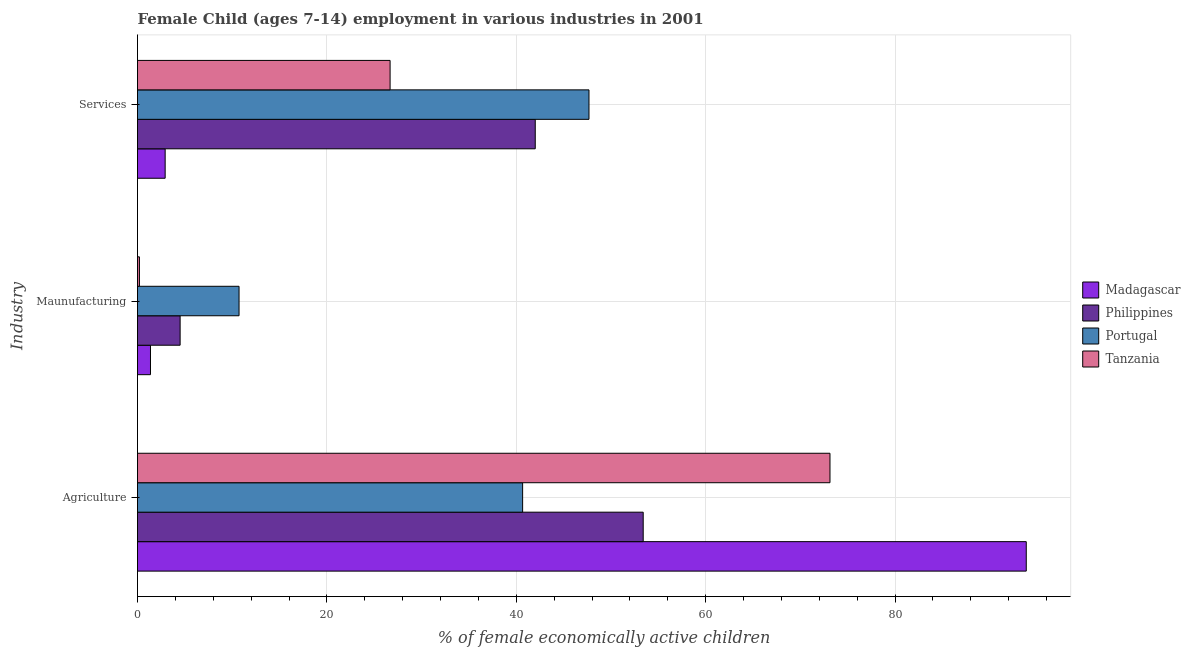How many groups of bars are there?
Ensure brevity in your answer.  3. How many bars are there on the 3rd tick from the top?
Provide a succinct answer. 4. What is the label of the 3rd group of bars from the top?
Ensure brevity in your answer.  Agriculture. What is the percentage of economically active children in services in Portugal?
Your answer should be very brief. 47.67. Across all countries, what is the maximum percentage of economically active children in manufacturing?
Make the answer very short. 10.72. Across all countries, what is the minimum percentage of economically active children in agriculture?
Give a very brief answer. 40.67. In which country was the percentage of economically active children in agriculture maximum?
Ensure brevity in your answer.  Madagascar. In which country was the percentage of economically active children in services minimum?
Make the answer very short. Madagascar. What is the total percentage of economically active children in services in the graph?
Your answer should be very brief. 119.27. What is the difference between the percentage of economically active children in agriculture in Tanzania and that in Portugal?
Your response must be concise. 32.46. What is the difference between the percentage of economically active children in services in Portugal and the percentage of economically active children in manufacturing in Philippines?
Give a very brief answer. 43.17. What is the average percentage of economically active children in agriculture per country?
Ensure brevity in your answer.  65.26. What is the difference between the percentage of economically active children in agriculture and percentage of economically active children in manufacturing in Portugal?
Your response must be concise. 29.94. What is the ratio of the percentage of economically active children in services in Philippines to that in Madagascar?
Give a very brief answer. 14.38. Is the percentage of economically active children in manufacturing in Tanzania less than that in Philippines?
Offer a terse response. Yes. What is the difference between the highest and the second highest percentage of economically active children in services?
Your response must be concise. 5.67. What is the difference between the highest and the lowest percentage of economically active children in manufacturing?
Your answer should be very brief. 10.52. Is the sum of the percentage of economically active children in manufacturing in Madagascar and Portugal greater than the maximum percentage of economically active children in agriculture across all countries?
Offer a very short reply. No. What does the 1st bar from the top in Maunufacturing represents?
Your response must be concise. Tanzania. What does the 1st bar from the bottom in Services represents?
Offer a very short reply. Madagascar. How many bars are there?
Make the answer very short. 12. Are all the bars in the graph horizontal?
Provide a short and direct response. Yes. What is the difference between two consecutive major ticks on the X-axis?
Your answer should be compact. 20. Does the graph contain grids?
Offer a very short reply. Yes. What is the title of the graph?
Your answer should be compact. Female Child (ages 7-14) employment in various industries in 2001. Does "Lebanon" appear as one of the legend labels in the graph?
Your response must be concise. No. What is the label or title of the X-axis?
Ensure brevity in your answer.  % of female economically active children. What is the label or title of the Y-axis?
Your response must be concise. Industry. What is the % of female economically active children in Madagascar in Agriculture?
Give a very brief answer. 93.85. What is the % of female economically active children of Philippines in Agriculture?
Your answer should be very brief. 53.4. What is the % of female economically active children of Portugal in Agriculture?
Make the answer very short. 40.67. What is the % of female economically active children of Tanzania in Agriculture?
Provide a short and direct response. 73.12. What is the % of female economically active children in Madagascar in Maunufacturing?
Provide a short and direct response. 1.37. What is the % of female economically active children of Philippines in Maunufacturing?
Provide a succinct answer. 4.5. What is the % of female economically active children in Portugal in Maunufacturing?
Your answer should be compact. 10.72. What is the % of female economically active children in Tanzania in Maunufacturing?
Give a very brief answer. 0.2. What is the % of female economically active children of Madagascar in Services?
Ensure brevity in your answer.  2.92. What is the % of female economically active children in Portugal in Services?
Your response must be concise. 47.67. What is the % of female economically active children in Tanzania in Services?
Your answer should be very brief. 26.67. Across all Industry, what is the maximum % of female economically active children of Madagascar?
Provide a succinct answer. 93.85. Across all Industry, what is the maximum % of female economically active children of Philippines?
Your response must be concise. 53.4. Across all Industry, what is the maximum % of female economically active children of Portugal?
Your answer should be compact. 47.67. Across all Industry, what is the maximum % of female economically active children of Tanzania?
Give a very brief answer. 73.12. Across all Industry, what is the minimum % of female economically active children of Madagascar?
Provide a short and direct response. 1.37. Across all Industry, what is the minimum % of female economically active children of Portugal?
Ensure brevity in your answer.  10.72. Across all Industry, what is the minimum % of female economically active children of Tanzania?
Offer a terse response. 0.2. What is the total % of female economically active children in Madagascar in the graph?
Provide a succinct answer. 98.14. What is the total % of female economically active children in Philippines in the graph?
Make the answer very short. 99.9. What is the total % of female economically active children of Portugal in the graph?
Offer a terse response. 99.06. What is the total % of female economically active children in Tanzania in the graph?
Provide a succinct answer. 100. What is the difference between the % of female economically active children of Madagascar in Agriculture and that in Maunufacturing?
Provide a succinct answer. 92.48. What is the difference between the % of female economically active children in Philippines in Agriculture and that in Maunufacturing?
Provide a succinct answer. 48.9. What is the difference between the % of female economically active children of Portugal in Agriculture and that in Maunufacturing?
Offer a terse response. 29.94. What is the difference between the % of female economically active children in Tanzania in Agriculture and that in Maunufacturing?
Provide a succinct answer. 72.92. What is the difference between the % of female economically active children of Madagascar in Agriculture and that in Services?
Provide a short and direct response. 90.93. What is the difference between the % of female economically active children of Portugal in Agriculture and that in Services?
Your response must be concise. -7.01. What is the difference between the % of female economically active children in Tanzania in Agriculture and that in Services?
Your response must be concise. 46.45. What is the difference between the % of female economically active children of Madagascar in Maunufacturing and that in Services?
Offer a terse response. -1.55. What is the difference between the % of female economically active children in Philippines in Maunufacturing and that in Services?
Provide a succinct answer. -37.5. What is the difference between the % of female economically active children in Portugal in Maunufacturing and that in Services?
Provide a short and direct response. -36.95. What is the difference between the % of female economically active children of Tanzania in Maunufacturing and that in Services?
Provide a short and direct response. -26.47. What is the difference between the % of female economically active children of Madagascar in Agriculture and the % of female economically active children of Philippines in Maunufacturing?
Your response must be concise. 89.35. What is the difference between the % of female economically active children of Madagascar in Agriculture and the % of female economically active children of Portugal in Maunufacturing?
Your response must be concise. 83.13. What is the difference between the % of female economically active children of Madagascar in Agriculture and the % of female economically active children of Tanzania in Maunufacturing?
Your answer should be very brief. 93.65. What is the difference between the % of female economically active children of Philippines in Agriculture and the % of female economically active children of Portugal in Maunufacturing?
Offer a terse response. 42.68. What is the difference between the % of female economically active children in Philippines in Agriculture and the % of female economically active children in Tanzania in Maunufacturing?
Make the answer very short. 53.2. What is the difference between the % of female economically active children of Portugal in Agriculture and the % of female economically active children of Tanzania in Maunufacturing?
Provide a short and direct response. 40.46. What is the difference between the % of female economically active children in Madagascar in Agriculture and the % of female economically active children in Philippines in Services?
Make the answer very short. 51.85. What is the difference between the % of female economically active children in Madagascar in Agriculture and the % of female economically active children in Portugal in Services?
Offer a very short reply. 46.18. What is the difference between the % of female economically active children in Madagascar in Agriculture and the % of female economically active children in Tanzania in Services?
Your response must be concise. 67.18. What is the difference between the % of female economically active children of Philippines in Agriculture and the % of female economically active children of Portugal in Services?
Your answer should be compact. 5.73. What is the difference between the % of female economically active children in Philippines in Agriculture and the % of female economically active children in Tanzania in Services?
Provide a succinct answer. 26.73. What is the difference between the % of female economically active children in Portugal in Agriculture and the % of female economically active children in Tanzania in Services?
Your response must be concise. 13.99. What is the difference between the % of female economically active children in Madagascar in Maunufacturing and the % of female economically active children in Philippines in Services?
Offer a very short reply. -40.63. What is the difference between the % of female economically active children in Madagascar in Maunufacturing and the % of female economically active children in Portugal in Services?
Your answer should be compact. -46.3. What is the difference between the % of female economically active children of Madagascar in Maunufacturing and the % of female economically active children of Tanzania in Services?
Offer a very short reply. -25.3. What is the difference between the % of female economically active children of Philippines in Maunufacturing and the % of female economically active children of Portugal in Services?
Ensure brevity in your answer.  -43.17. What is the difference between the % of female economically active children of Philippines in Maunufacturing and the % of female economically active children of Tanzania in Services?
Provide a succinct answer. -22.17. What is the difference between the % of female economically active children in Portugal in Maunufacturing and the % of female economically active children in Tanzania in Services?
Provide a succinct answer. -15.95. What is the average % of female economically active children of Madagascar per Industry?
Provide a succinct answer. 32.71. What is the average % of female economically active children in Philippines per Industry?
Offer a very short reply. 33.3. What is the average % of female economically active children of Portugal per Industry?
Keep it short and to the point. 33.02. What is the average % of female economically active children of Tanzania per Industry?
Your response must be concise. 33.33. What is the difference between the % of female economically active children in Madagascar and % of female economically active children in Philippines in Agriculture?
Give a very brief answer. 40.45. What is the difference between the % of female economically active children in Madagascar and % of female economically active children in Portugal in Agriculture?
Your answer should be compact. 53.18. What is the difference between the % of female economically active children in Madagascar and % of female economically active children in Tanzania in Agriculture?
Keep it short and to the point. 20.73. What is the difference between the % of female economically active children in Philippines and % of female economically active children in Portugal in Agriculture?
Provide a short and direct response. 12.73. What is the difference between the % of female economically active children in Philippines and % of female economically active children in Tanzania in Agriculture?
Provide a succinct answer. -19.72. What is the difference between the % of female economically active children of Portugal and % of female economically active children of Tanzania in Agriculture?
Your response must be concise. -32.46. What is the difference between the % of female economically active children of Madagascar and % of female economically active children of Philippines in Maunufacturing?
Your response must be concise. -3.13. What is the difference between the % of female economically active children of Madagascar and % of female economically active children of Portugal in Maunufacturing?
Keep it short and to the point. -9.35. What is the difference between the % of female economically active children of Madagascar and % of female economically active children of Tanzania in Maunufacturing?
Your answer should be very brief. 1.17. What is the difference between the % of female economically active children in Philippines and % of female economically active children in Portugal in Maunufacturing?
Your response must be concise. -6.22. What is the difference between the % of female economically active children of Philippines and % of female economically active children of Tanzania in Maunufacturing?
Provide a short and direct response. 4.3. What is the difference between the % of female economically active children of Portugal and % of female economically active children of Tanzania in Maunufacturing?
Ensure brevity in your answer.  10.52. What is the difference between the % of female economically active children of Madagascar and % of female economically active children of Philippines in Services?
Your answer should be compact. -39.08. What is the difference between the % of female economically active children in Madagascar and % of female economically active children in Portugal in Services?
Provide a short and direct response. -44.75. What is the difference between the % of female economically active children in Madagascar and % of female economically active children in Tanzania in Services?
Your answer should be compact. -23.75. What is the difference between the % of female economically active children of Philippines and % of female economically active children of Portugal in Services?
Offer a very short reply. -5.67. What is the difference between the % of female economically active children in Philippines and % of female economically active children in Tanzania in Services?
Make the answer very short. 15.33. What is the difference between the % of female economically active children of Portugal and % of female economically active children of Tanzania in Services?
Provide a short and direct response. 21. What is the ratio of the % of female economically active children in Madagascar in Agriculture to that in Maunufacturing?
Provide a short and direct response. 68.5. What is the ratio of the % of female economically active children in Philippines in Agriculture to that in Maunufacturing?
Offer a terse response. 11.87. What is the ratio of the % of female economically active children in Portugal in Agriculture to that in Maunufacturing?
Provide a short and direct response. 3.79. What is the ratio of the % of female economically active children in Tanzania in Agriculture to that in Maunufacturing?
Ensure brevity in your answer.  360.16. What is the ratio of the % of female economically active children of Madagascar in Agriculture to that in Services?
Keep it short and to the point. 32.14. What is the ratio of the % of female economically active children in Philippines in Agriculture to that in Services?
Offer a very short reply. 1.27. What is the ratio of the % of female economically active children of Portugal in Agriculture to that in Services?
Keep it short and to the point. 0.85. What is the ratio of the % of female economically active children in Tanzania in Agriculture to that in Services?
Offer a terse response. 2.74. What is the ratio of the % of female economically active children of Madagascar in Maunufacturing to that in Services?
Provide a short and direct response. 0.47. What is the ratio of the % of female economically active children of Philippines in Maunufacturing to that in Services?
Your answer should be very brief. 0.11. What is the ratio of the % of female economically active children of Portugal in Maunufacturing to that in Services?
Provide a short and direct response. 0.22. What is the ratio of the % of female economically active children in Tanzania in Maunufacturing to that in Services?
Offer a terse response. 0.01. What is the difference between the highest and the second highest % of female economically active children in Madagascar?
Keep it short and to the point. 90.93. What is the difference between the highest and the second highest % of female economically active children in Portugal?
Provide a short and direct response. 7.01. What is the difference between the highest and the second highest % of female economically active children in Tanzania?
Your answer should be compact. 46.45. What is the difference between the highest and the lowest % of female economically active children of Madagascar?
Offer a terse response. 92.48. What is the difference between the highest and the lowest % of female economically active children in Philippines?
Provide a short and direct response. 48.9. What is the difference between the highest and the lowest % of female economically active children of Portugal?
Offer a terse response. 36.95. What is the difference between the highest and the lowest % of female economically active children of Tanzania?
Make the answer very short. 72.92. 